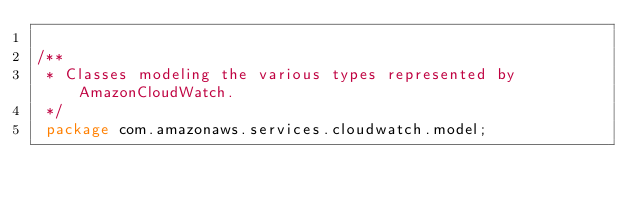Convert code to text. <code><loc_0><loc_0><loc_500><loc_500><_Java_>
/**
 * Classes modeling the various types represented by AmazonCloudWatch.
 */
 package com.amazonaws.services.cloudwatch.model;
        </code> 